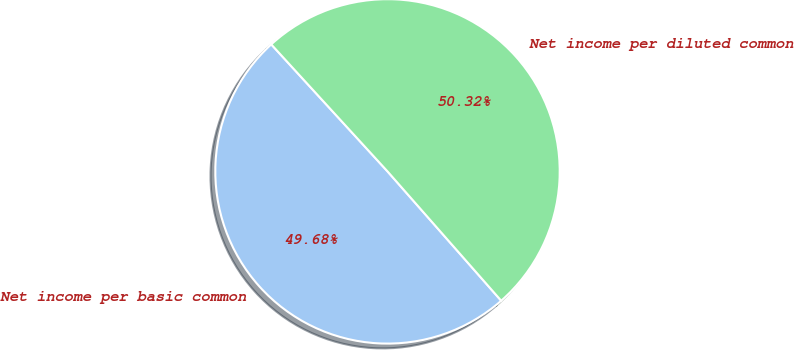Convert chart to OTSL. <chart><loc_0><loc_0><loc_500><loc_500><pie_chart><fcel>Net income per basic common<fcel>Net income per diluted common<nl><fcel>49.68%<fcel>50.32%<nl></chart> 